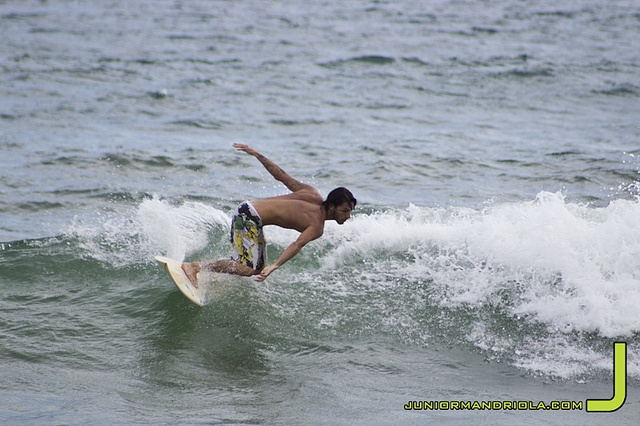Describe the objects in this image and their specific colors. I can see people in gray, black, and darkgray tones and surfboard in gray, lightgray, darkgray, and tan tones in this image. 